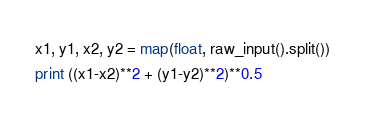<code> <loc_0><loc_0><loc_500><loc_500><_Python_>x1, y1, x2, y2 = map(float, raw_input().split())
print ((x1-x2)**2 + (y1-y2)**2)**0.5</code> 